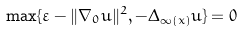Convert formula to latex. <formula><loc_0><loc_0><loc_500><loc_500>\max \{ \varepsilon - \| \nabla _ { 0 } u \| ^ { 2 } , - \Delta _ { \infty ( x ) } u \} = 0</formula> 